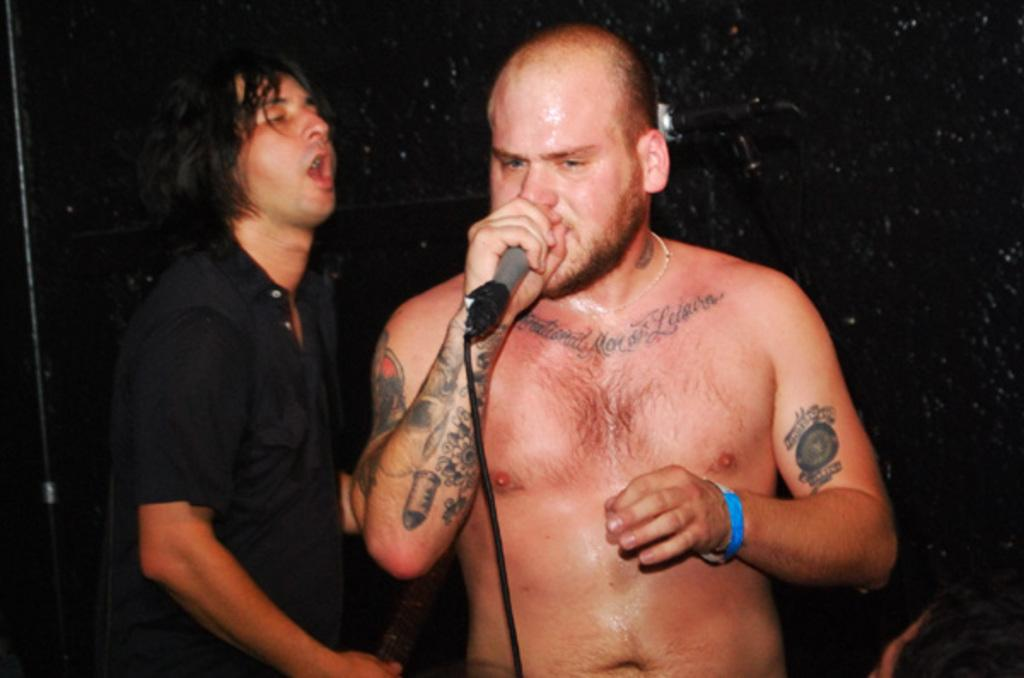What is the person in the image holding? The person is holding a microphone. Can you describe the person on the left side of the image? The person on the left is wearing a black dress. What object is present in the image that is used to support the microphone? There is a microphone stand in the image. How many people are visible in the image? There are two people visible in the image. What type of tomatoes are being traded by the passengers in the image? There are no tomatoes or passengers present in the image; it features a person holding a microphone and another person wearing a black dress. 